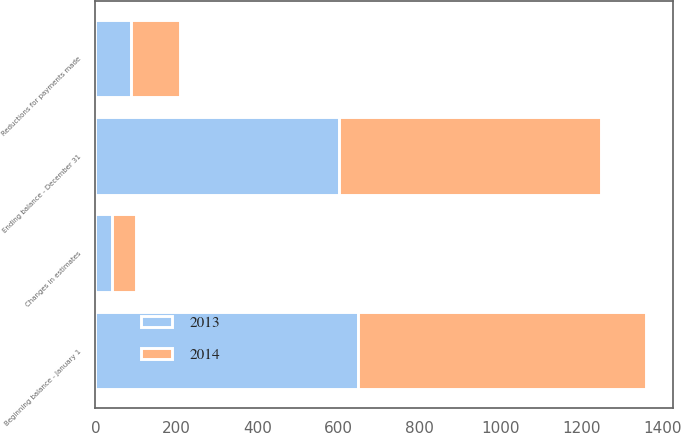Convert chart. <chart><loc_0><loc_0><loc_500><loc_500><stacked_bar_chart><ecel><fcel>Beginning balance - January 1<fcel>Reductions for payments made<fcel>Changes in estimates<fcel>Ending balance - December 31<nl><fcel>2013<fcel>649<fcel>89<fcel>41<fcel>601<nl><fcel>2014<fcel>710<fcel>120<fcel>59<fcel>649<nl></chart> 